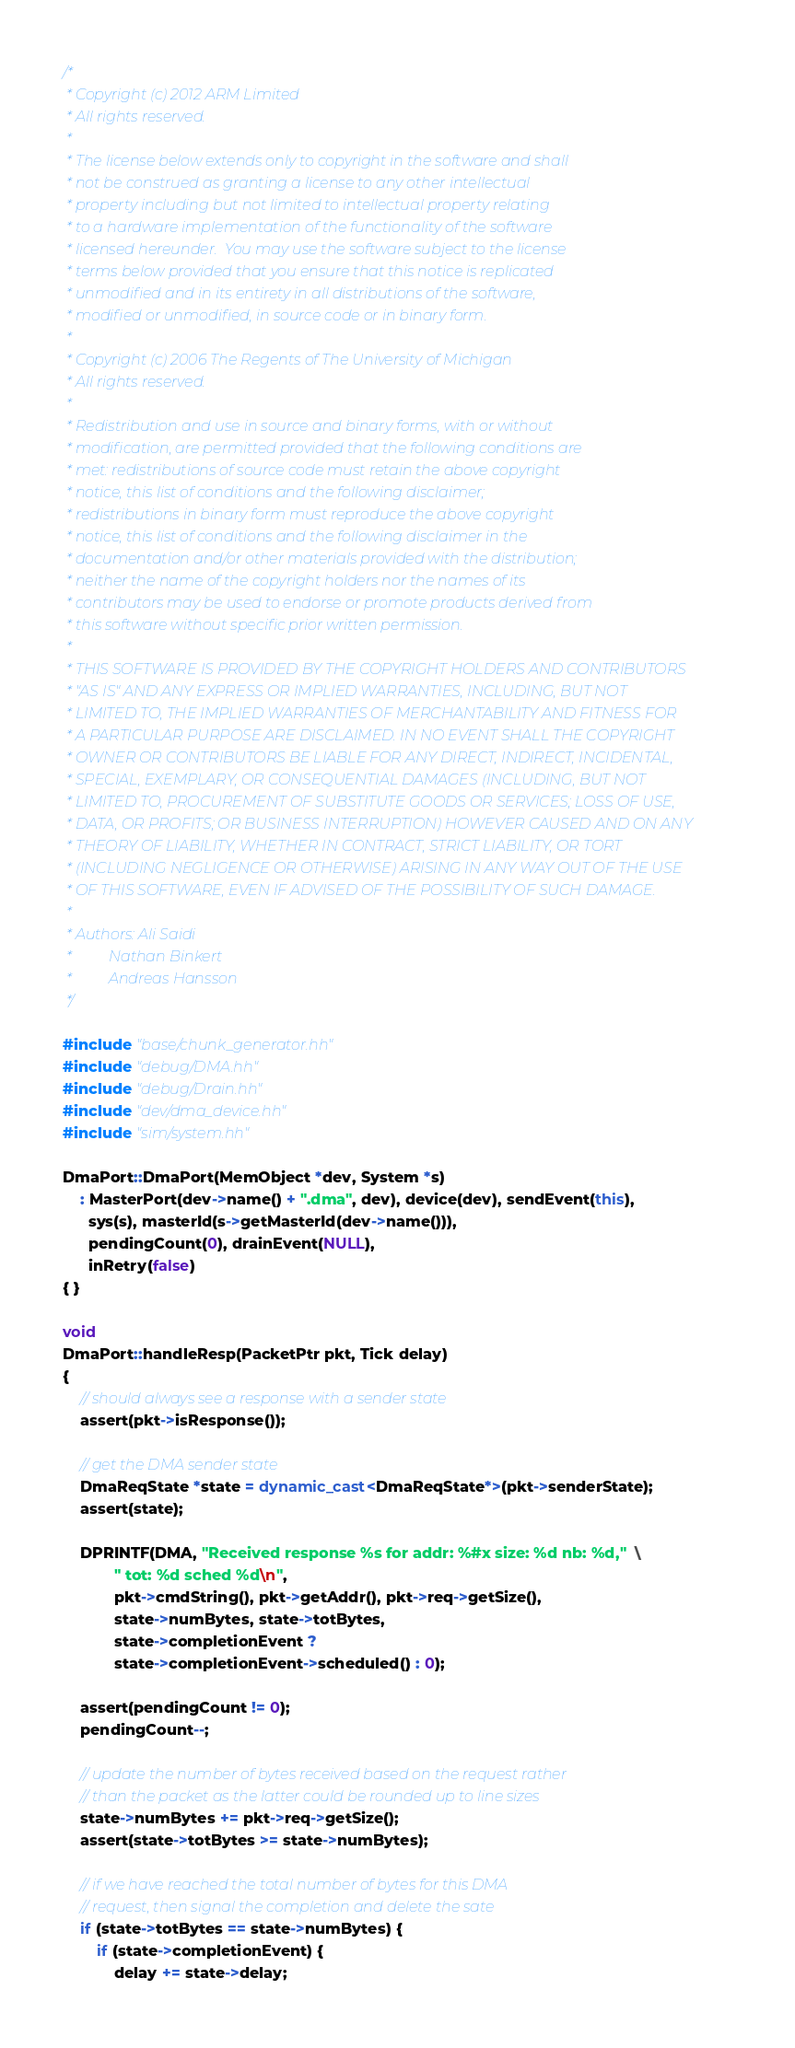<code> <loc_0><loc_0><loc_500><loc_500><_C++_>/*
 * Copyright (c) 2012 ARM Limited
 * All rights reserved.
 *
 * The license below extends only to copyright in the software and shall
 * not be construed as granting a license to any other intellectual
 * property including but not limited to intellectual property relating
 * to a hardware implementation of the functionality of the software
 * licensed hereunder.  You may use the software subject to the license
 * terms below provided that you ensure that this notice is replicated
 * unmodified and in its entirety in all distributions of the software,
 * modified or unmodified, in source code or in binary form.
 *
 * Copyright (c) 2006 The Regents of The University of Michigan
 * All rights reserved.
 *
 * Redistribution and use in source and binary forms, with or without
 * modification, are permitted provided that the following conditions are
 * met: redistributions of source code must retain the above copyright
 * notice, this list of conditions and the following disclaimer;
 * redistributions in binary form must reproduce the above copyright
 * notice, this list of conditions and the following disclaimer in the
 * documentation and/or other materials provided with the distribution;
 * neither the name of the copyright holders nor the names of its
 * contributors may be used to endorse or promote products derived from
 * this software without specific prior written permission.
 *
 * THIS SOFTWARE IS PROVIDED BY THE COPYRIGHT HOLDERS AND CONTRIBUTORS
 * "AS IS" AND ANY EXPRESS OR IMPLIED WARRANTIES, INCLUDING, BUT NOT
 * LIMITED TO, THE IMPLIED WARRANTIES OF MERCHANTABILITY AND FITNESS FOR
 * A PARTICULAR PURPOSE ARE DISCLAIMED. IN NO EVENT SHALL THE COPYRIGHT
 * OWNER OR CONTRIBUTORS BE LIABLE FOR ANY DIRECT, INDIRECT, INCIDENTAL,
 * SPECIAL, EXEMPLARY, OR CONSEQUENTIAL DAMAGES (INCLUDING, BUT NOT
 * LIMITED TO, PROCUREMENT OF SUBSTITUTE GOODS OR SERVICES; LOSS OF USE,
 * DATA, OR PROFITS; OR BUSINESS INTERRUPTION) HOWEVER CAUSED AND ON ANY
 * THEORY OF LIABILITY, WHETHER IN CONTRACT, STRICT LIABILITY, OR TORT
 * (INCLUDING NEGLIGENCE OR OTHERWISE) ARISING IN ANY WAY OUT OF THE USE
 * OF THIS SOFTWARE, EVEN IF ADVISED OF THE POSSIBILITY OF SUCH DAMAGE.
 *
 * Authors: Ali Saidi
 *          Nathan Binkert
 *          Andreas Hansson
 */

#include "base/chunk_generator.hh"
#include "debug/DMA.hh"
#include "debug/Drain.hh"
#include "dev/dma_device.hh"
#include "sim/system.hh"

DmaPort::DmaPort(MemObject *dev, System *s)
    : MasterPort(dev->name() + ".dma", dev), device(dev), sendEvent(this),
      sys(s), masterId(s->getMasterId(dev->name())),
      pendingCount(0), drainEvent(NULL),
      inRetry(false)
{ }

void
DmaPort::handleResp(PacketPtr pkt, Tick delay)
{
    // should always see a response with a sender state
    assert(pkt->isResponse());

    // get the DMA sender state
    DmaReqState *state = dynamic_cast<DmaReqState*>(pkt->senderState);
    assert(state);

    DPRINTF(DMA, "Received response %s for addr: %#x size: %d nb: %d,"  \
            " tot: %d sched %d\n",
            pkt->cmdString(), pkt->getAddr(), pkt->req->getSize(),
            state->numBytes, state->totBytes,
            state->completionEvent ?
            state->completionEvent->scheduled() : 0);

    assert(pendingCount != 0);
    pendingCount--;

    // update the number of bytes received based on the request rather
    // than the packet as the latter could be rounded up to line sizes
    state->numBytes += pkt->req->getSize();
    assert(state->totBytes >= state->numBytes);

    // if we have reached the total number of bytes for this DMA
    // request, then signal the completion and delete the sate
    if (state->totBytes == state->numBytes) {
        if (state->completionEvent) {
            delay += state->delay;</code> 